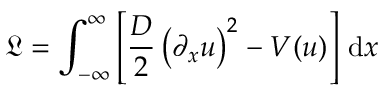<formula> <loc_0><loc_0><loc_500><loc_500>{ \mathfrak { L } } = \int _ { - \infty } ^ { \infty } \left [ { \frac { D } { 2 } } \left ( \partial _ { x } u \right ) ^ { 2 } - V ( u ) \right ] \, { d } x</formula> 